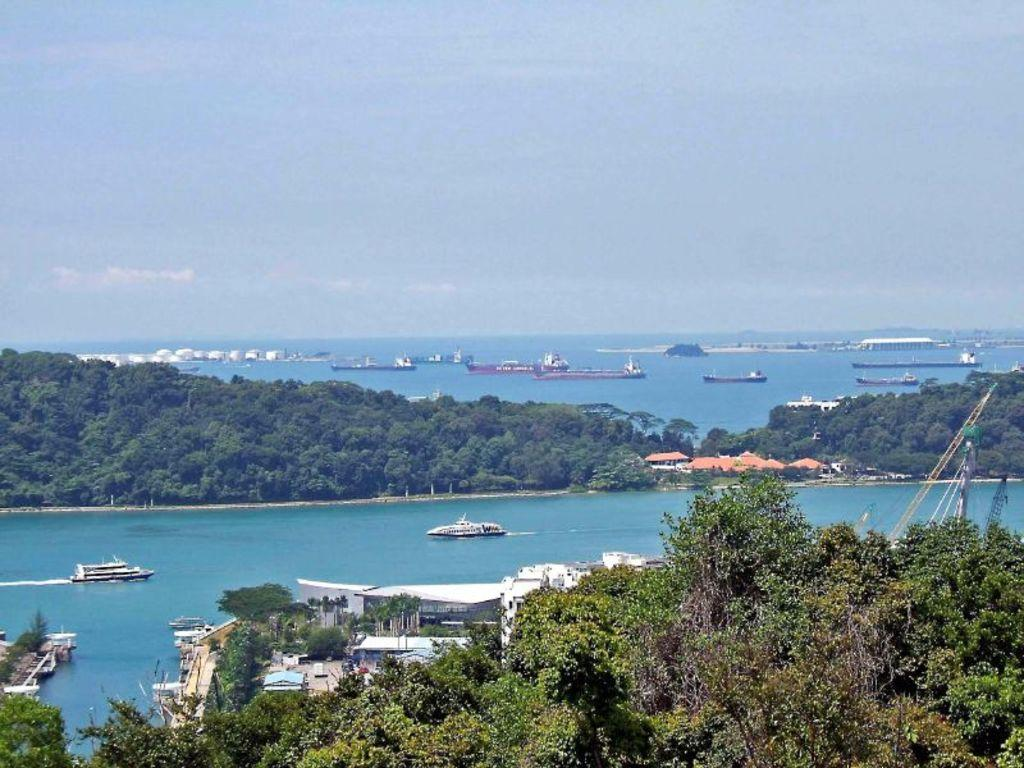What type of natural elements can be seen in the image? There are trees in the image. What type of man-made structures are present in the image? There are buildings in the image. What is on the water in the image? There are ships on the water in the image. What type of machinery is visible on the right side of the image? There are cranes on the right side of the image. What can be seen in the background of the image? There are clouds visible in the background of the image. Can you tell me how many feet are visible in the image? There are no feet present in the image. What type of face can be seen on the crane in the image? There are no faces present in the image, as cranes are inanimate objects. 